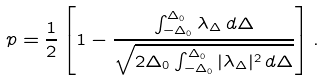Convert formula to latex. <formula><loc_0><loc_0><loc_500><loc_500>p = \frac { 1 } { 2 } \left [ 1 - \frac { \int _ { - \Delta _ { 0 } } ^ { \Delta _ { 0 } } \lambda _ { \Delta } \, d \Delta } { \sqrt { 2 \Delta _ { 0 } \int _ { - \Delta _ { 0 } } ^ { \Delta _ { 0 } } | \lambda _ { \Delta } | ^ { 2 } \, d \Delta } } \right ] .</formula> 